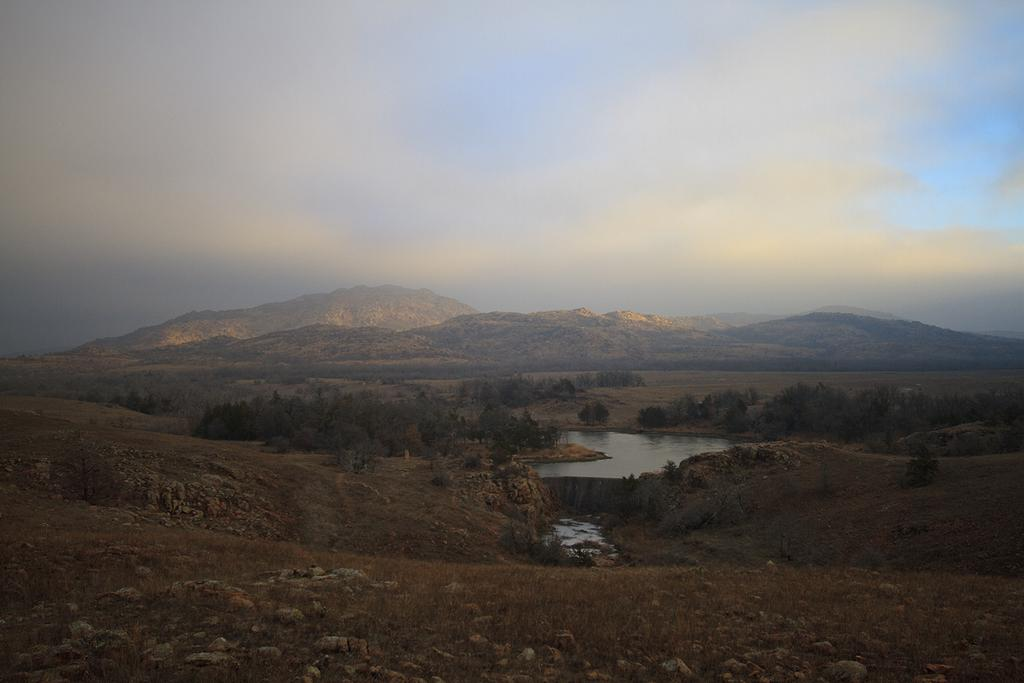What type of vegetation is present on the land in the image? There are trees on the land in the image. What body of water can be seen in the image? There is a pond in the middle of the image. What geographical features are visible in the background of the image? There are hills in the background of the image. What can be seen in the sky in the background of the image? There are clouds in the sky in the background of the image. How many cherries can be seen on the kitten in the image? There is no kitten or cherry present in the image. What attempt is being made by the person in the image? There is no person or attempt depicted in the image. 